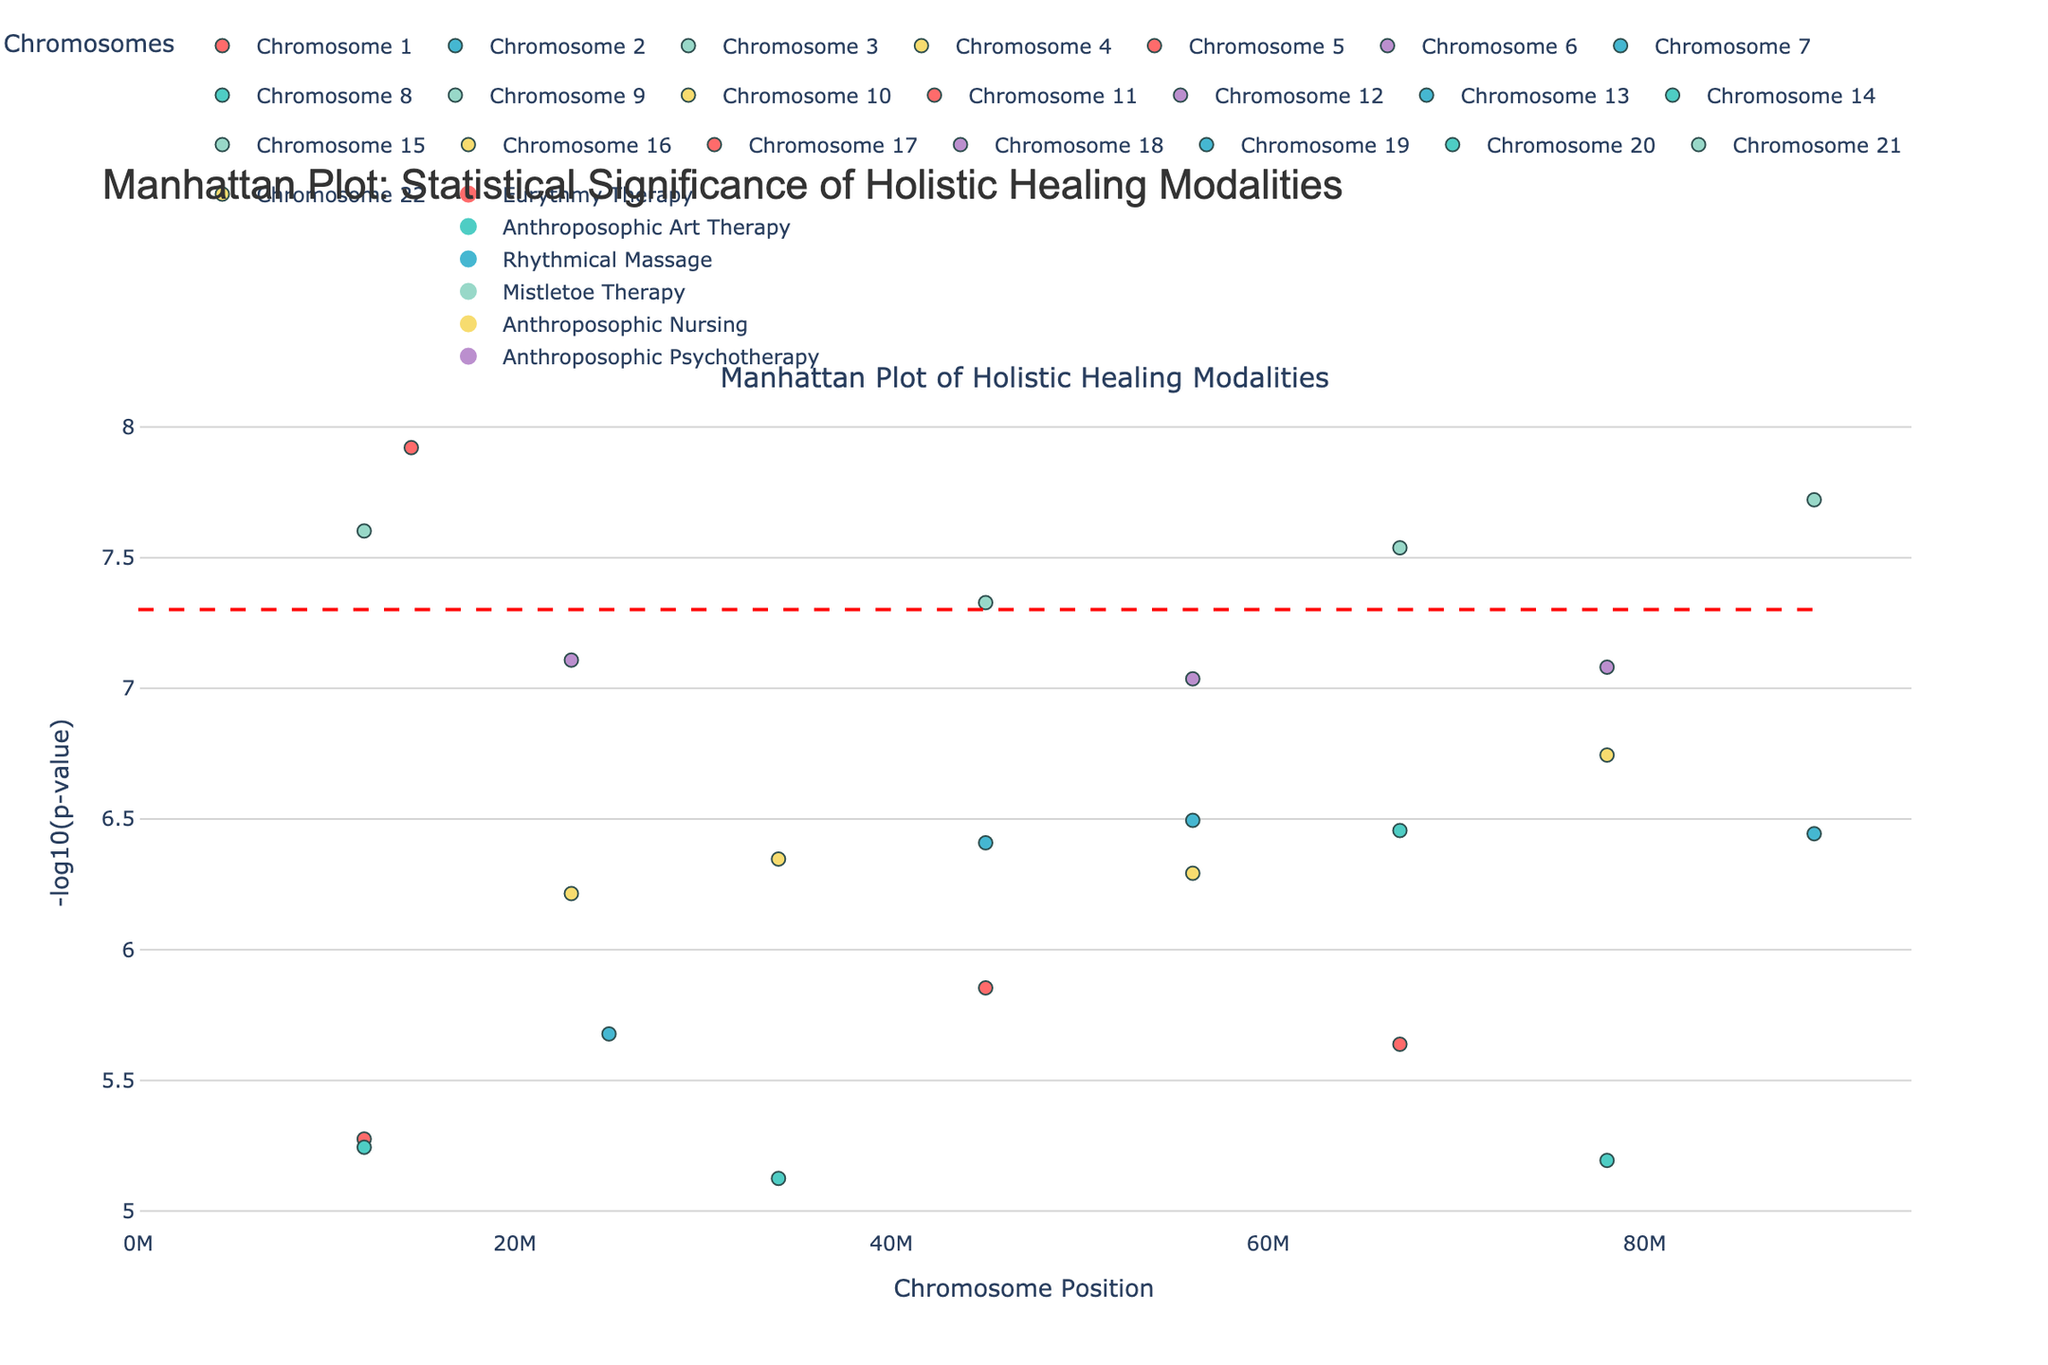What is the title of the figure? The title is usually placed at the top of the plot. In this case, the title given at the top is "Manhattan Plot: Statistical Significance of Holistic Healing Modalities".
Answer: Manhattan Plot: Statistical Significance of Holistic Healing Modalities Which chromosome has the highest significance for any condition? We look for the data point with the highest -log10(p-value) on the y-axis. The data point on chromosome 1 with Eurythmy Therapy for Rheumatoid Arthritis has the highest value, -log10(1.2e-8) = 8.92.
Answer: Chromosome 1 What does the red dashed line in the plot represent? According to the code, the red dashed line represents the significance threshold at -log10(5e-8). Values above this line are considered significant.
Answer: Significance threshold Which modality has the most significant results on average across conditions and chromosomes? We need to compare the average -log10(p-value) for each modality. This requires calculating the average for each group of modality. For instance - 
Eurythmy Therapy = (-log10(1.2e-8) + -log10(5.3e-6) + -log10(2.3e-6)) / 3 = 7.92 
The full calculation requires repeating this for each modality and comparing.
Answer: Probably Mistletoe Therapy Which modality is associated with more than one significant condition (p-value < 5e-8)? We review the significant data points above the threshold and note their modalities. Mistletoe Therapy is associated with several points such as Type 2 Diabetes, Osteoarthritis, and Coronary Heart Disease.
Answer: Mistletoe Therapy Which condition corresponding to chromosome 3 has the data point with the highest significance? By looking at chromosome 3, we identify the condition with the highest -log10(p-value). Here, it is Depression treated with Mistletoe Therapy at -log10(4.7e-8).
Answer: Depression How many conditions are associated with Eurythmy Therapy? We count the number of conditions listed under Eurythmy Therapy in the dataset. There are four: Rheumatoid Arthritis, Irritable Bowel Syndrome, Multiple Sclerosis, and Peptic Ulcer.
Answer: Four Between Rhythmical Massage for Chronic Pain and Anthroposophic Nursing for Allergies, which has a higher significance level? We compare the -log10(p-values) of Rhythmical Massage for Chronic Pain (3.2e-7) and Anthroposophic Psychotherapy for Allergies (8.3e-8). - log10(p-value) of 3.2e-7 < -log10(p-value) of 8.3e-8.
Answer: Anthroposophic Psychotherapy What color represents the Rhythmic Massage modality in the plot? Based on the color mapping in the provided code, Rhythmic Massage is represented by the color "#45B7D1". Since the hexadecimal value is not necessary, it is essentially a blue shade.
Answer: Blue shade 